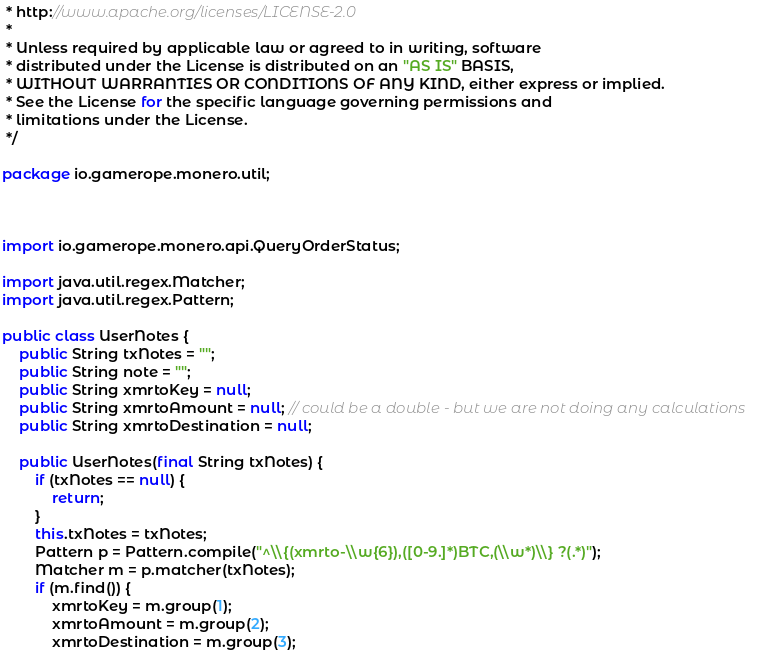<code> <loc_0><loc_0><loc_500><loc_500><_Java_> * http://www.apache.org/licenses/LICENSE-2.0
 *
 * Unless required by applicable law or agreed to in writing, software
 * distributed under the License is distributed on an "AS IS" BASIS,
 * WITHOUT WARRANTIES OR CONDITIONS OF ANY KIND, either express or implied.
 * See the License for the specific language governing permissions and
 * limitations under the License.
 */

package io.gamerope.monero.util;



import io.gamerope.monero.api.QueryOrderStatus;

import java.util.regex.Matcher;
import java.util.regex.Pattern;

public class UserNotes {
    public String txNotes = "";
    public String note = "";
    public String xmrtoKey = null;
    public String xmrtoAmount = null; // could be a double - but we are not doing any calculations
    public String xmrtoDestination = null;

    public UserNotes(final String txNotes) {
        if (txNotes == null) {
            return;
        }
        this.txNotes = txNotes;
        Pattern p = Pattern.compile("^\\{(xmrto-\\w{6}),([0-9.]*)BTC,(\\w*)\\} ?(.*)");
        Matcher m = p.matcher(txNotes);
        if (m.find()) {
            xmrtoKey = m.group(1);
            xmrtoAmount = m.group(2);
            xmrtoDestination = m.group(3);</code> 